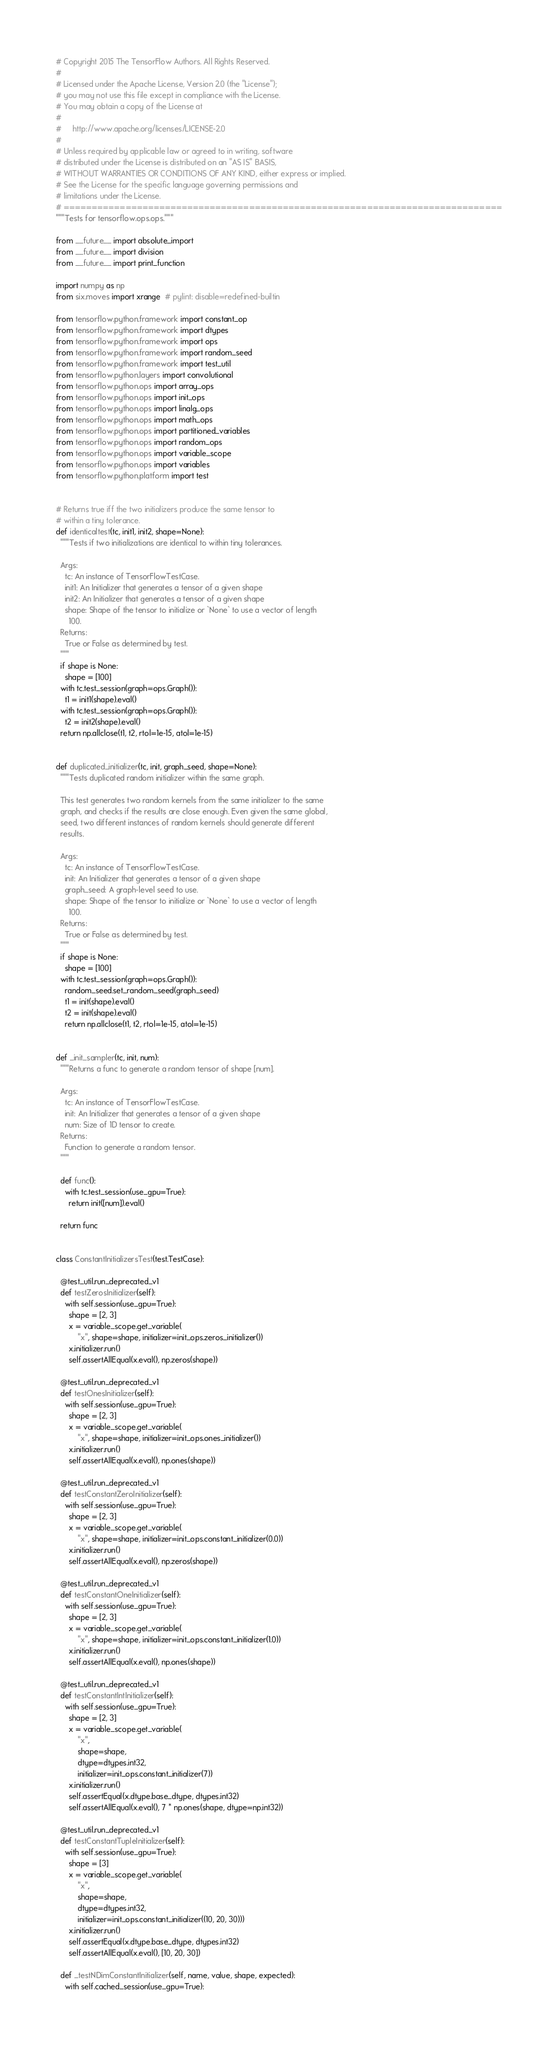Convert code to text. <code><loc_0><loc_0><loc_500><loc_500><_Python_># Copyright 2015 The TensorFlow Authors. All Rights Reserved.
#
# Licensed under the Apache License, Version 2.0 (the "License");
# you may not use this file except in compliance with the License.
# You may obtain a copy of the License at
#
#     http://www.apache.org/licenses/LICENSE-2.0
#
# Unless required by applicable law or agreed to in writing, software
# distributed under the License is distributed on an "AS IS" BASIS,
# WITHOUT WARRANTIES OR CONDITIONS OF ANY KIND, either express or implied.
# See the License for the specific language governing permissions and
# limitations under the License.
# ==============================================================================
"""Tests for tensorflow.ops.ops."""

from __future__ import absolute_import
from __future__ import division
from __future__ import print_function

import numpy as np
from six.moves import xrange  # pylint: disable=redefined-builtin

from tensorflow.python.framework import constant_op
from tensorflow.python.framework import dtypes
from tensorflow.python.framework import ops
from tensorflow.python.framework import random_seed
from tensorflow.python.framework import test_util
from tensorflow.python.layers import convolutional
from tensorflow.python.ops import array_ops
from tensorflow.python.ops import init_ops
from tensorflow.python.ops import linalg_ops
from tensorflow.python.ops import math_ops
from tensorflow.python.ops import partitioned_variables
from tensorflow.python.ops import random_ops
from tensorflow.python.ops import variable_scope
from tensorflow.python.ops import variables
from tensorflow.python.platform import test


# Returns true iff the two initializers produce the same tensor to
# within a tiny tolerance.
def identicaltest(tc, init1, init2, shape=None):
  """Tests if two initializations are identical to within tiny tolerances.

  Args:
    tc: An instance of TensorFlowTestCase.
    init1: An Initializer that generates a tensor of a given shape
    init2: An Initializer that generates a tensor of a given shape
    shape: Shape of the tensor to initialize or `None` to use a vector of length
      100.
  Returns:
    True or False as determined by test.
  """
  if shape is None:
    shape = [100]
  with tc.test_session(graph=ops.Graph()):
    t1 = init1(shape).eval()
  with tc.test_session(graph=ops.Graph()):
    t2 = init2(shape).eval()
  return np.allclose(t1, t2, rtol=1e-15, atol=1e-15)


def duplicated_initializer(tc, init, graph_seed, shape=None):
  """Tests duplicated random initializer within the same graph.

  This test generates two random kernels from the same initializer to the same
  graph, and checks if the results are close enough. Even given the same global,
  seed, two different instances of random kernels should generate different
  results.

  Args:
    tc: An instance of TensorFlowTestCase.
    init: An Initializer that generates a tensor of a given shape
    graph_seed: A graph-level seed to use.
    shape: Shape of the tensor to initialize or `None` to use a vector of length
      100.
  Returns:
    True or False as determined by test.
  """
  if shape is None:
    shape = [100]
  with tc.test_session(graph=ops.Graph()):
    random_seed.set_random_seed(graph_seed)
    t1 = init(shape).eval()
    t2 = init(shape).eval()
    return np.allclose(t1, t2, rtol=1e-15, atol=1e-15)


def _init_sampler(tc, init, num):
  """Returns a func to generate a random tensor of shape [num].

  Args:
    tc: An instance of TensorFlowTestCase.
    init: An Initializer that generates a tensor of a given shape
    num: Size of 1D tensor to create.
  Returns:
    Function to generate a random tensor.
  """

  def func():
    with tc.test_session(use_gpu=True):
      return init([num]).eval()

  return func


class ConstantInitializersTest(test.TestCase):

  @test_util.run_deprecated_v1
  def testZerosInitializer(self):
    with self.session(use_gpu=True):
      shape = [2, 3]
      x = variable_scope.get_variable(
          "x", shape=shape, initializer=init_ops.zeros_initializer())
      x.initializer.run()
      self.assertAllEqual(x.eval(), np.zeros(shape))

  @test_util.run_deprecated_v1
  def testOnesInitializer(self):
    with self.session(use_gpu=True):
      shape = [2, 3]
      x = variable_scope.get_variable(
          "x", shape=shape, initializer=init_ops.ones_initializer())
      x.initializer.run()
      self.assertAllEqual(x.eval(), np.ones(shape))

  @test_util.run_deprecated_v1
  def testConstantZeroInitializer(self):
    with self.session(use_gpu=True):
      shape = [2, 3]
      x = variable_scope.get_variable(
          "x", shape=shape, initializer=init_ops.constant_initializer(0.0))
      x.initializer.run()
      self.assertAllEqual(x.eval(), np.zeros(shape))

  @test_util.run_deprecated_v1
  def testConstantOneInitializer(self):
    with self.session(use_gpu=True):
      shape = [2, 3]
      x = variable_scope.get_variable(
          "x", shape=shape, initializer=init_ops.constant_initializer(1.0))
      x.initializer.run()
      self.assertAllEqual(x.eval(), np.ones(shape))

  @test_util.run_deprecated_v1
  def testConstantIntInitializer(self):
    with self.session(use_gpu=True):
      shape = [2, 3]
      x = variable_scope.get_variable(
          "x",
          shape=shape,
          dtype=dtypes.int32,
          initializer=init_ops.constant_initializer(7))
      x.initializer.run()
      self.assertEqual(x.dtype.base_dtype, dtypes.int32)
      self.assertAllEqual(x.eval(), 7 * np.ones(shape, dtype=np.int32))

  @test_util.run_deprecated_v1
  def testConstantTupleInitializer(self):
    with self.session(use_gpu=True):
      shape = [3]
      x = variable_scope.get_variable(
          "x",
          shape=shape,
          dtype=dtypes.int32,
          initializer=init_ops.constant_initializer((10, 20, 30)))
      x.initializer.run()
      self.assertEqual(x.dtype.base_dtype, dtypes.int32)
      self.assertAllEqual(x.eval(), [10, 20, 30])

  def _testNDimConstantInitializer(self, name, value, shape, expected):
    with self.cached_session(use_gpu=True):</code> 